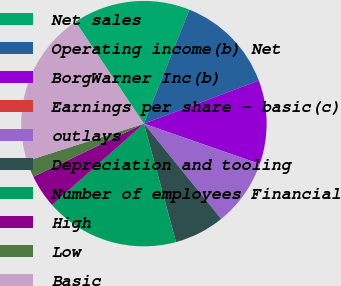<chart> <loc_0><loc_0><loc_500><loc_500><pie_chart><fcel>Net sales<fcel>Operating income(b) Net<fcel>BorgWarner Inc(b)<fcel>Earnings per share - basic(c)<fcel>outlays<fcel>Depreciation and tooling<fcel>Number of employees Financial<fcel>High<fcel>Low<fcel>Basic<nl><fcel>15.46%<fcel>13.25%<fcel>11.04%<fcel>0.0%<fcel>8.83%<fcel>6.63%<fcel>17.67%<fcel>4.42%<fcel>2.21%<fcel>20.5%<nl></chart> 